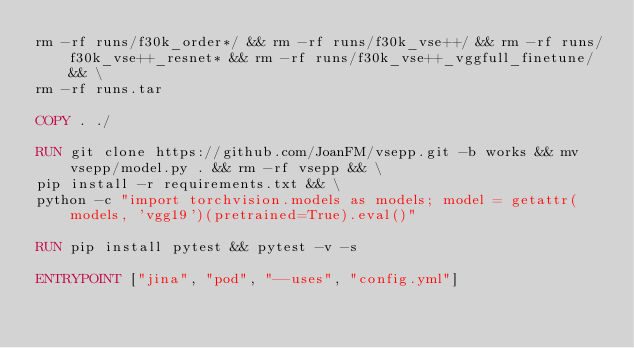Convert code to text. <code><loc_0><loc_0><loc_500><loc_500><_Dockerfile_>rm -rf runs/f30k_order*/ && rm -rf runs/f30k_vse++/ && rm -rf runs/f30k_vse++_resnet* && rm -rf runs/f30k_vse++_vggfull_finetune/ && \
rm -rf runs.tar

COPY . ./

RUN git clone https://github.com/JoanFM/vsepp.git -b works && mv vsepp/model.py . && rm -rf vsepp && \
pip install -r requirements.txt && \
python -c "import torchvision.models as models; model = getattr(models, 'vgg19')(pretrained=True).eval()"

RUN pip install pytest && pytest -v -s

ENTRYPOINT ["jina", "pod", "--uses", "config.yml"]
</code> 